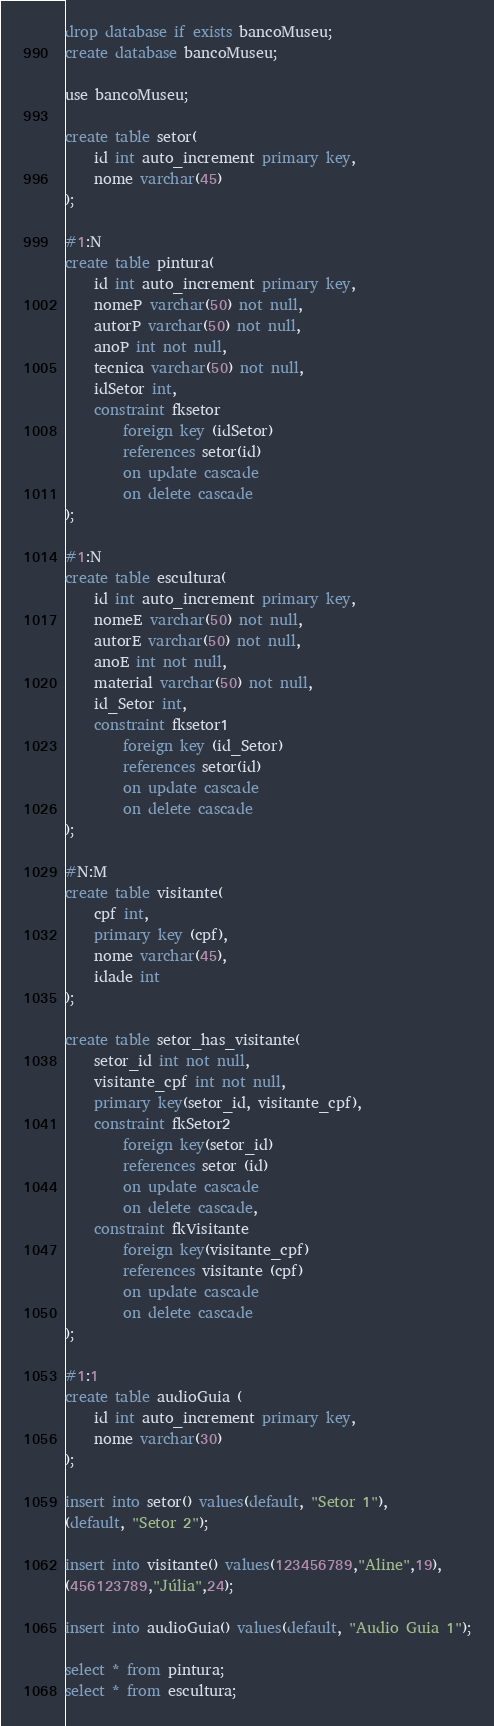Convert code to text. <code><loc_0><loc_0><loc_500><loc_500><_SQL_>drop database if exists bancoMuseu;
create database bancoMuseu;

use bancoMuseu;

create table setor(
	id int auto_increment primary key,
    nome varchar(45)
);

#1:N
create table pintura(
	id int auto_increment primary key,
    nomeP varchar(50) not null,
    autorP varchar(50) not null,
    anoP int not null,
    tecnica varchar(50) not null,
    idSetor int,
    constraint fksetor
		foreign key (idSetor)
        references setor(id)
        on update cascade
        on delete cascade
);

#1:N
create table escultura(
	id int auto_increment primary key,
    nomeE varchar(50) not null,
    autorE varchar(50) not null,
    anoE int not null,
    material varchar(50) not null,
    id_Setor int,
    constraint fksetor1
		foreign key (id_Setor)
        references setor(id)
        on update cascade
        on delete cascade
);

#N:M
create table visitante(
	cpf int,
    primary key (cpf),
    nome varchar(45),
    idade int
);

create table setor_has_visitante(
	setor_id int not null,
    visitante_cpf int not null,
    primary key(setor_id, visitante_cpf),
    constraint fkSetor2
		foreign key(setor_id)
        references setor (id)
        on update cascade
        on delete cascade,
	constraint fkVisitante
		foreign key(visitante_cpf)
        references visitante (cpf)
        on update cascade
        on delete cascade
);

#1:1
create table audioGuia (
	id int auto_increment primary key,
    nome varchar(30)
);

insert into setor() values(default, "Setor 1"),
(default, "Setor 2");

insert into visitante() values(123456789,"Aline",19),
(456123789,"Júlia",24);

insert into audioGuia() values(default, "Audio Guia 1");

select * from pintura;
select * from escultura;





</code> 